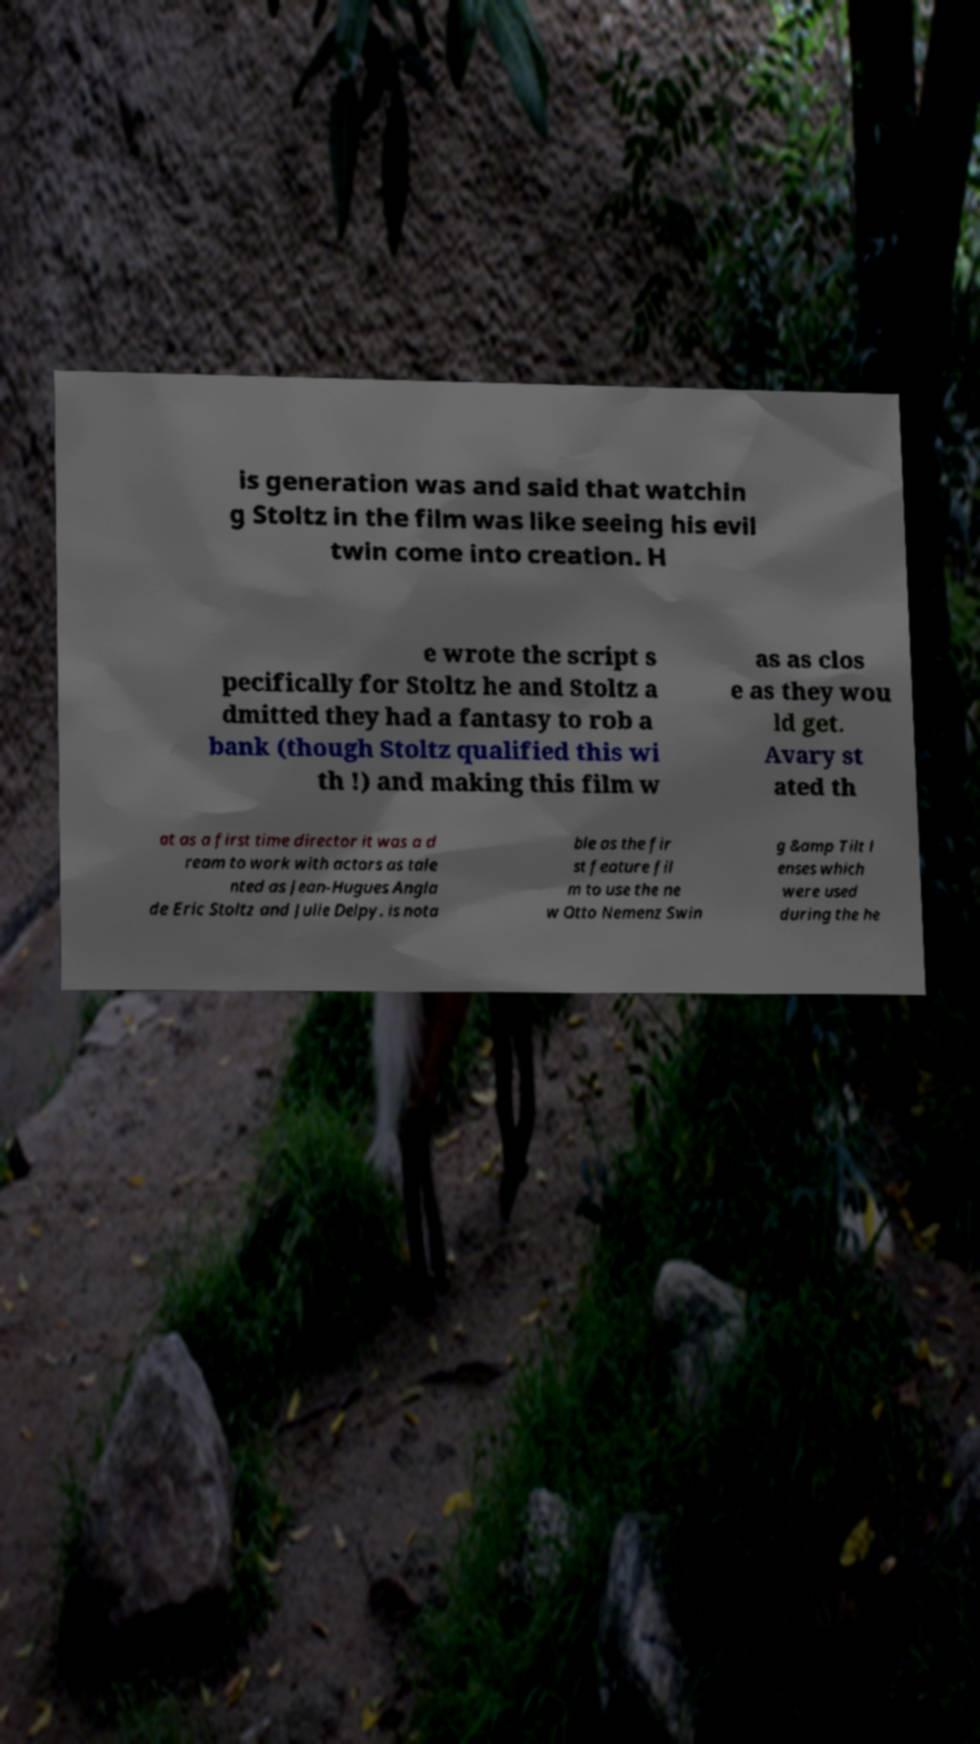There's text embedded in this image that I need extracted. Can you transcribe it verbatim? is generation was and said that watchin g Stoltz in the film was like seeing his evil twin come into creation. H e wrote the script s pecifically for Stoltz he and Stoltz a dmitted they had a fantasy to rob a bank (though Stoltz qualified this wi th !) and making this film w as as clos e as they wou ld get. Avary st ated th at as a first time director it was a d ream to work with actors as tale nted as Jean-Hugues Angla de Eric Stoltz and Julie Delpy. is nota ble as the fir st feature fil m to use the ne w Otto Nemenz Swin g &amp Tilt l enses which were used during the he 